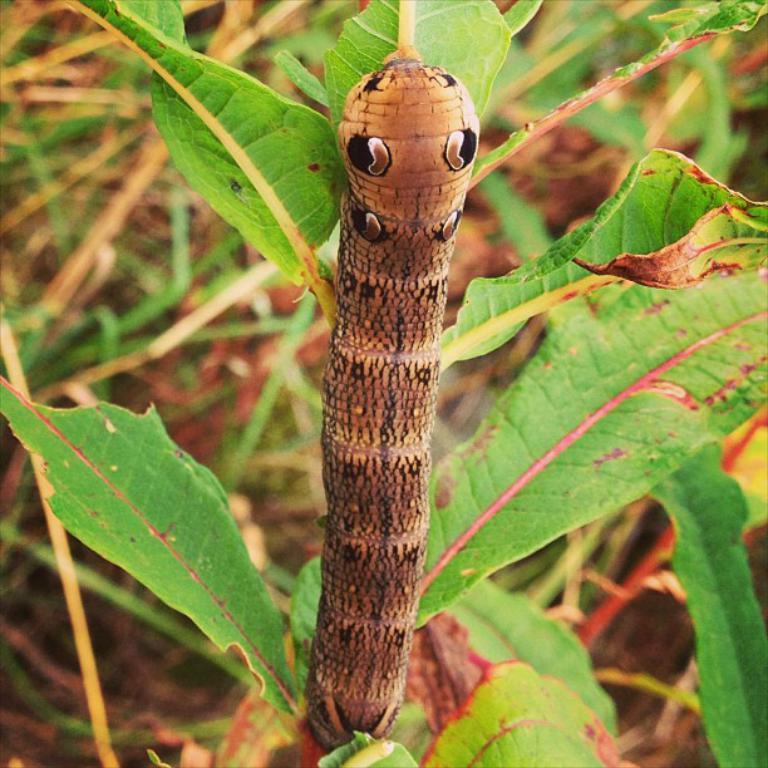Please provide a concise description of this image. This image is taken outdoors. In the background there is a ground with grass on it. In the middle of the image there is a plant with green leaves and there is a caterpillar on the plant. 